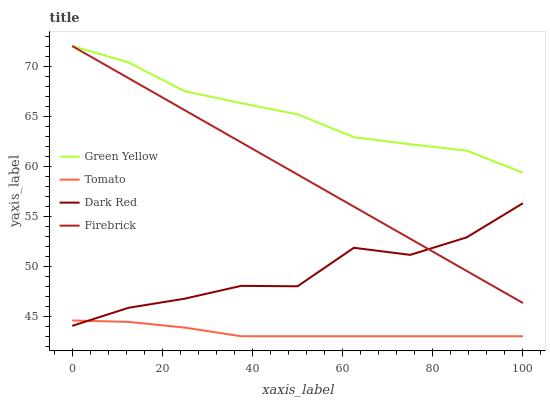Does Tomato have the minimum area under the curve?
Answer yes or no. Yes. Does Green Yellow have the maximum area under the curve?
Answer yes or no. Yes. Does Dark Red have the minimum area under the curve?
Answer yes or no. No. Does Dark Red have the maximum area under the curve?
Answer yes or no. No. Is Firebrick the smoothest?
Answer yes or no. Yes. Is Dark Red the roughest?
Answer yes or no. Yes. Is Dark Red the smoothest?
Answer yes or no. No. Is Firebrick the roughest?
Answer yes or no. No. Does Tomato have the lowest value?
Answer yes or no. Yes. Does Dark Red have the lowest value?
Answer yes or no. No. Does Green Yellow have the highest value?
Answer yes or no. Yes. Does Dark Red have the highest value?
Answer yes or no. No. Is Tomato less than Green Yellow?
Answer yes or no. Yes. Is Green Yellow greater than Dark Red?
Answer yes or no. Yes. Does Green Yellow intersect Firebrick?
Answer yes or no. Yes. Is Green Yellow less than Firebrick?
Answer yes or no. No. Is Green Yellow greater than Firebrick?
Answer yes or no. No. Does Tomato intersect Green Yellow?
Answer yes or no. No. 